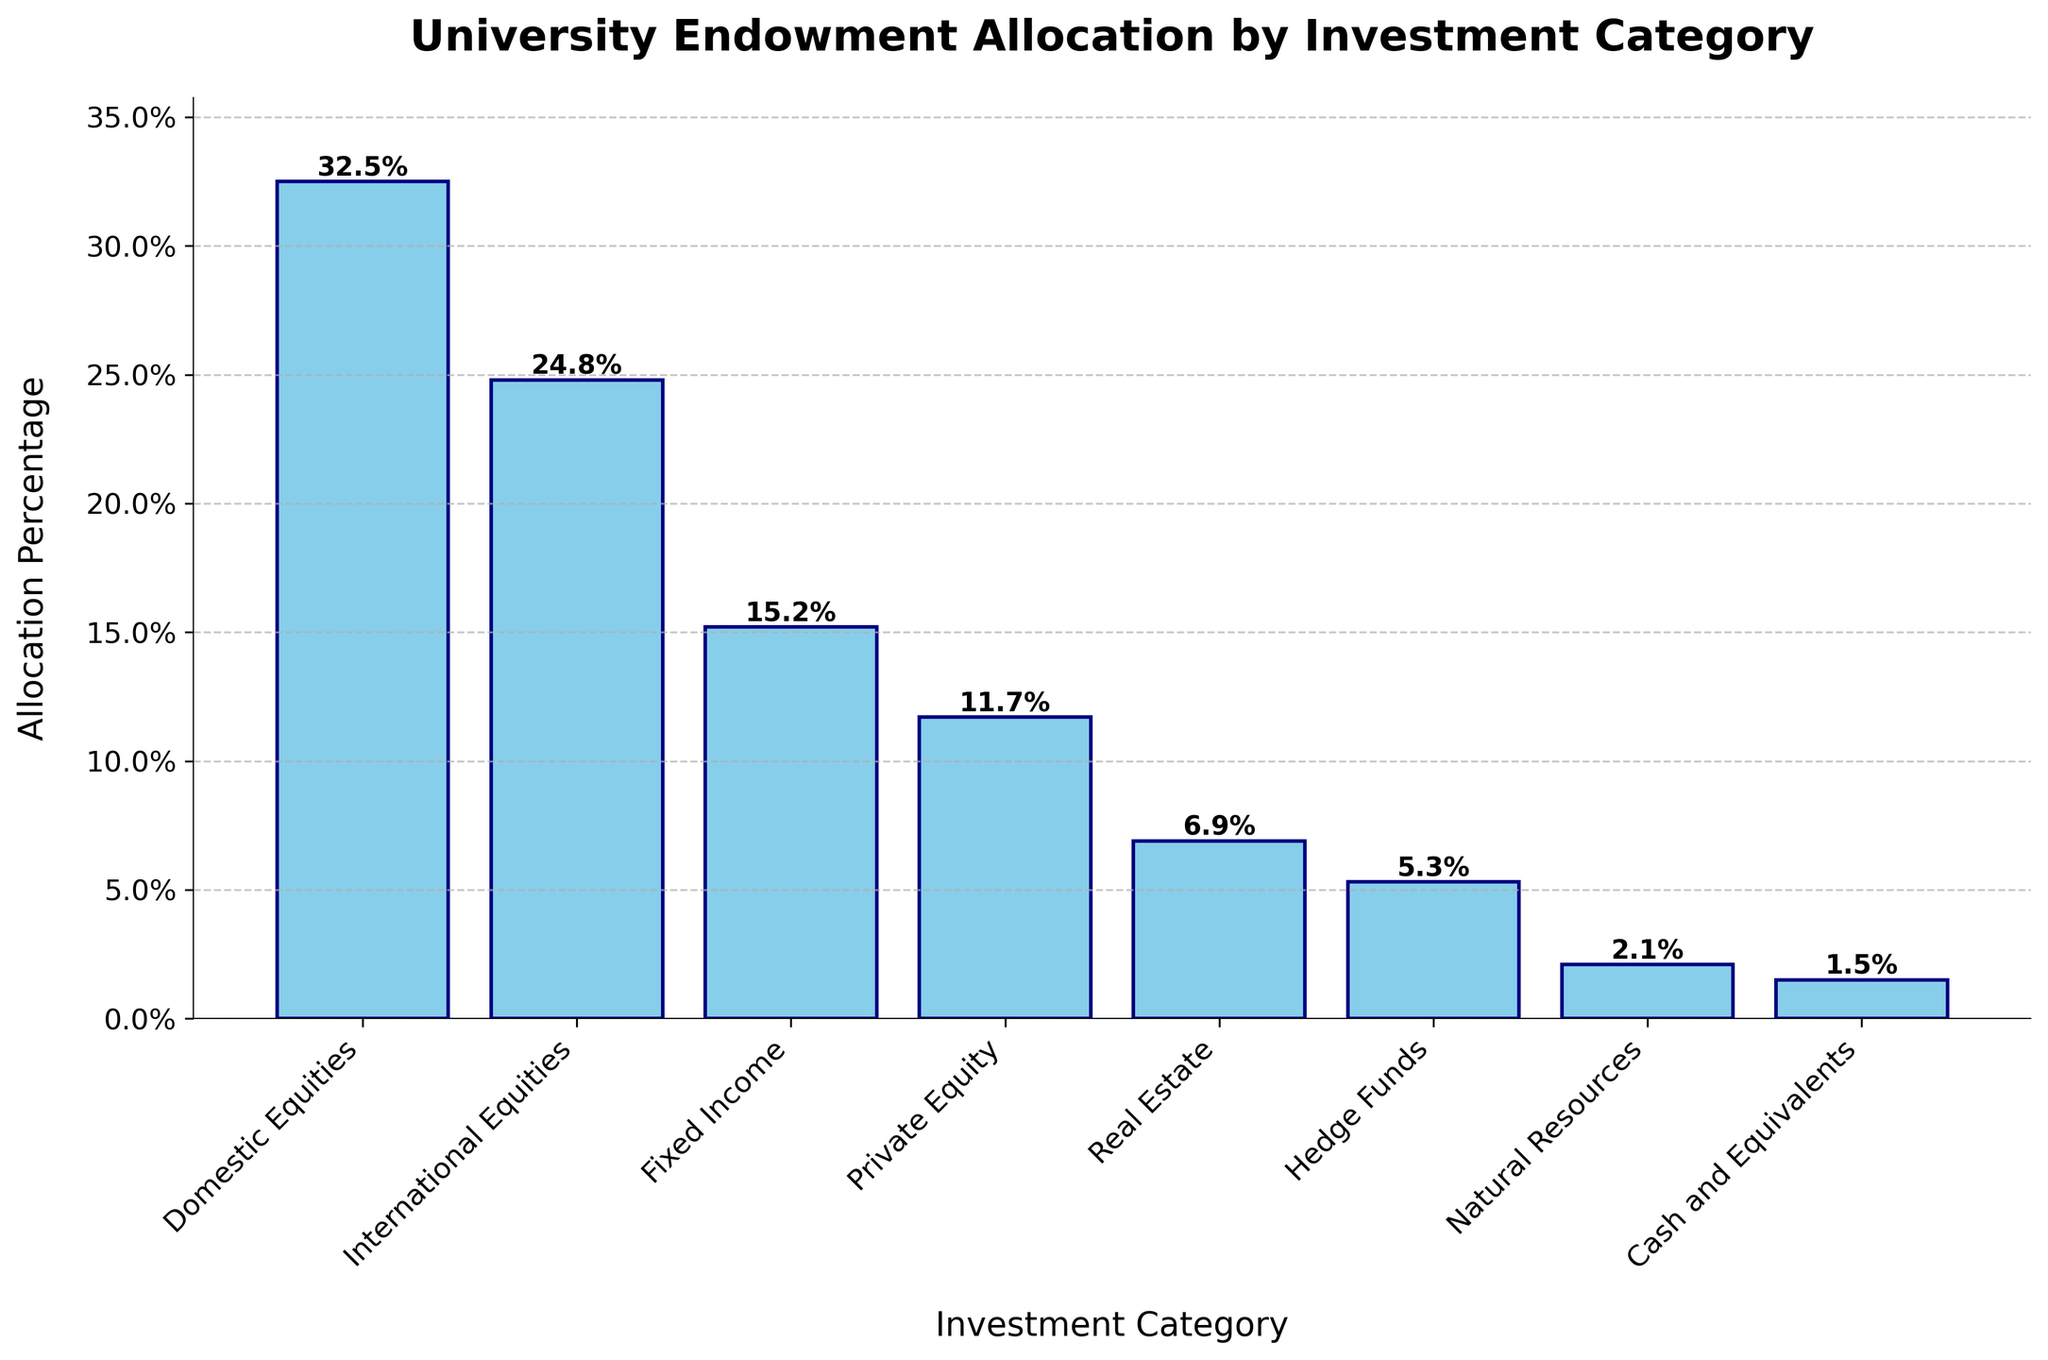What is the highest allocation percentage among the investment categories? Identify the tallest bar, which represents the highest allocation. The tallest bar corresponds to Domestic Equities with an allocation percentage of 32.5%.
Answer: 32.5% What is the difference in allocation percentage between Domestic Equities and Cash and Equivalents? Subtract the allocation percentage of Cash and Equivalents (1.5%) from Domestic Equities (32.5%). So, 32.5% - 1.5% = 31%.
Answer: 31% Which investment category has a higher allocation: Fixed Income or Real Estate? Compare the heights of the bars for Fixed Income (15.2%) and Real Estate (6.9%). The bar for Fixed Income is taller, so it has a higher allocation.
Answer: Fixed Income How much more is allocated to Private Equity compared to Hedge Funds? Subtract the allocation percentage of Hedge Funds (5.3%) from Private Equity (11.7%). So, 11.7% - 5.3% = 6.4%.
Answer: 6.4% Which investment category has the second-largest allocation? Identify the bars and find the one with the second tallest height after Domestic Equities. The second tallest bar is International Equities with an allocation percentage of 24.8%.
Answer: International Equities What is the combined allocation percentage for Natural Resources and Cash and Equivalents? Add the allocation percentages of Natural Resources (2.1%) and Cash and Equivalents (1.5%). So, 2.1% + 1.5% = 3.6%.
Answer: 3.6% What is the average allocation percentage of the categories: Real Estate, Hedge Funds, and Natural Resources? Add their allocation percentages and divide by the number of categories. (6.9% + 5.3% + 2.1%) / 3 = 14.3% / 3 = 4.77%.
Answer: 4.77% Which category has the smallest allocation percentage? Identify the shortest bar, which represents the smallest allocation. The shortest bar corresponds to Cash and Equivalents with an allocation of 1.5%.
Answer: Cash and Equivalents How much more is allocated to International Equities than to Natural Resources and Cash and Equivalents combined? Find the combined allocation percentage of Natural Resources and Cash and Equivalents (2.1% + 1.5% = 3.6%) and subtract it from the allocation percentage of International Equities (24.8%). So, 24.8% - 3.6% = 21.2%.
Answer: 21.2% 